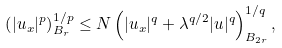Convert formula to latex. <formula><loc_0><loc_0><loc_500><loc_500>\left ( | u _ { x } | ^ { p } \right ) ^ { 1 / p } _ { B _ { r } } \leq N \left ( | u _ { x } | ^ { q } + \lambda ^ { q / 2 } | u | ^ { q } \right ) ^ { 1 / q } _ { B _ { 2 r } } ,</formula> 